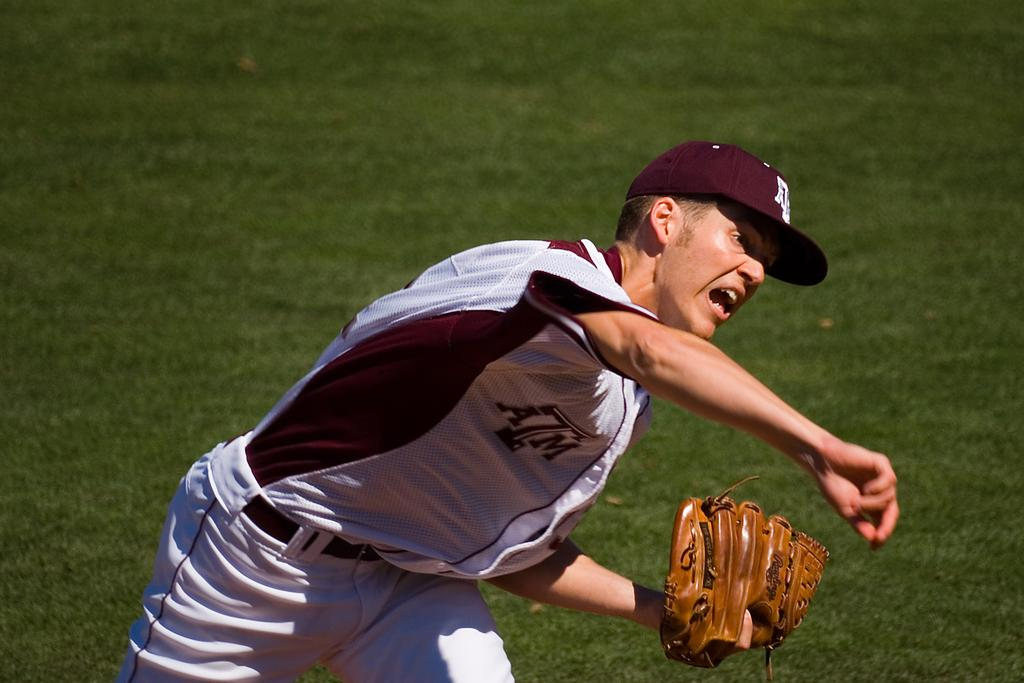<image>
Give a short and clear explanation of the subsequent image. A baseball pitcher has the letters ATM on his shirt. 